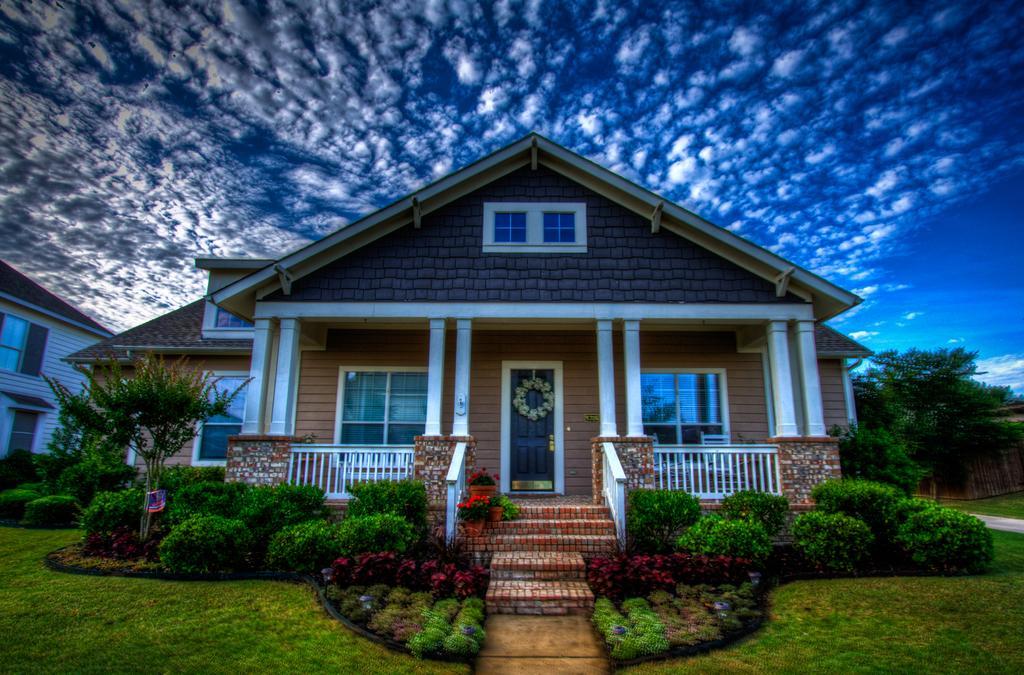How would you summarize this image in a sentence or two? In this image we can see buildings with windows. In the foreground we can see the pillars, roof and staircase, railings, group of plants. In the background, we can see a group of trees and the sky. 